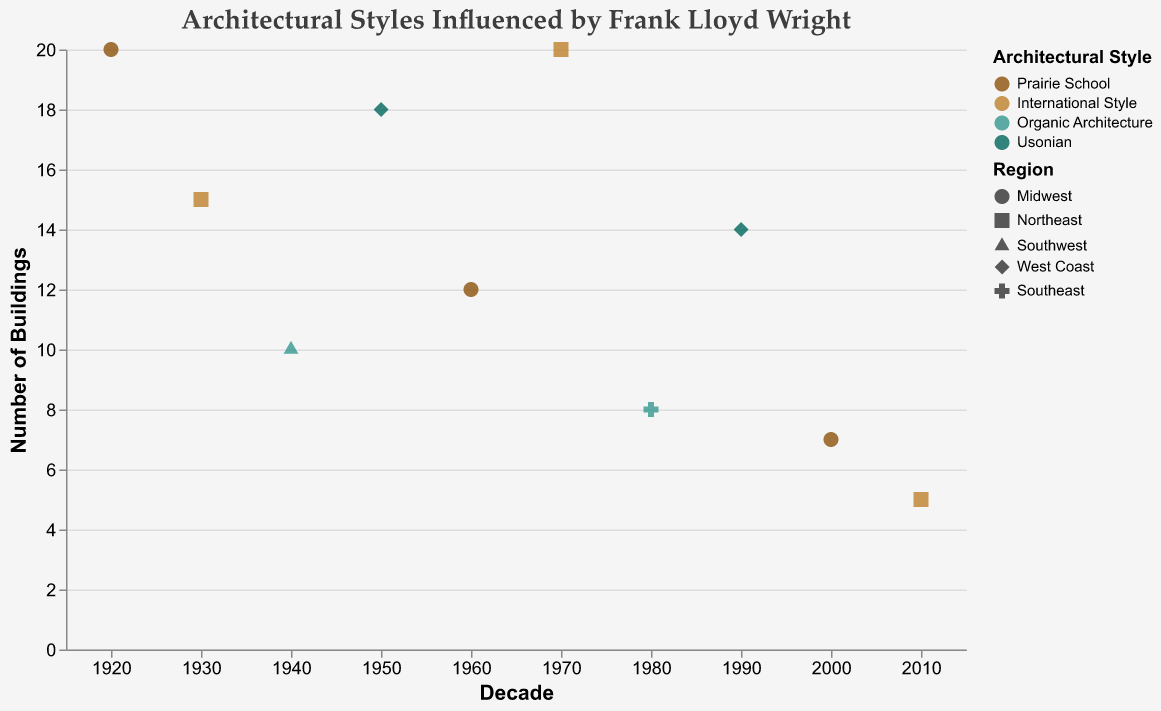How many buildings were influenced by Frank Lloyd Wright in the 1940s? The grouped scatter plot provides a point for the 1940s decade, labeled "1940," with the "Number of Buildings" value. Check the y-axis value for this point.
Answer: 10 Which architectural style has the highest number of buildings influenced by Frank Lloyd Wright in any decade? Look for the tallest point on the y-axis and check the corresponding color, which represents the "Architectural Style" field.
Answer: Prairie School In which decade did the Northeast region see the highest influence of Frank Lloyd Wright's architectural styles? Locate the points corresponding to the Northeast region by their shape (square) and identify the decade with the highest y-value.
Answer: 1970 Which region had buildings influenced by the Usonian style by Frank Lloyd Wright in the 1950s? Find the points for the 1950s decade and look for the shape color corresponding to the Usonian style, then check the shape for the region.
Answer: West Coast Compare the number of buildings influenced by Frank Lloyd Wright in the Midwest during the 1920s and 1960s. How many more buildings were influenced in the 1920s? Identify the points for the Midwest region (circle shape) in the 1920s and 1960s decades, then subtract the number of buildings in the 1960s from that in the 1920s.
Answer: 8 Which architectural style shows a continuous decrease in the number of buildings influenced by Frank Lloyd Wright from 1950 to 2010? Examine the points corresponding to the Usonian style color marker across the decades from 1950 to 2010 to see if the y-axis values decrease continuously.
Answer: Usonian How many total buildings were influenced by Frank Lloyd Wright in the Northeast region across all decades? Sum the y-axis values of all points marked with the square shape (Northeast region) across the decades.
Answer: 40 What is the difference in the number of buildings influenced by Frank Lloyd Wright between the Midwest and the Northeast in the 2010s? Find the points for the Midwest and Northeast in the 2010s, then calculate the difference between their y-axis values.
Answer: 2 Which architectural style had buildings in the Southeast region, and in what decade? Identify the shape corresponding to the Southeast region (cross) and check the associated color to determine the architectural style and decade.
Answer: Organic Architecture, 1980 Which decade saw a decline in buildings influenced by Frank Lloyd Wright across the most architectural styles? Compare changes in y-axis values for each architectural style between consecutive decades to identify the decade with the most decreases.
Answer: 2010 